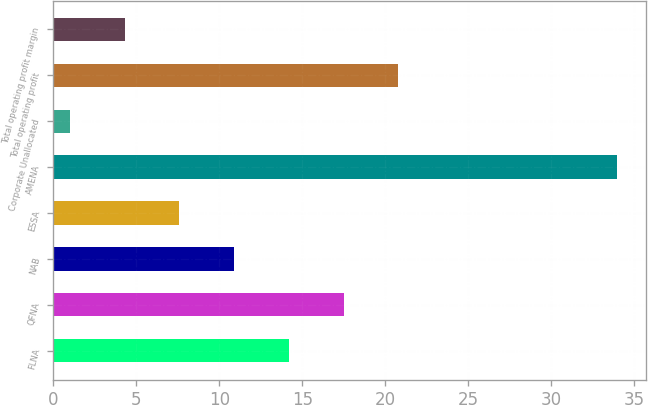Convert chart. <chart><loc_0><loc_0><loc_500><loc_500><bar_chart><fcel>FLNA<fcel>QFNA<fcel>NAB<fcel>ESSA<fcel>AMENA<fcel>Corporate Unallocated<fcel>Total operating profit<fcel>Total operating profit margin<nl><fcel>14.2<fcel>17.5<fcel>10.9<fcel>7.6<fcel>34<fcel>1<fcel>20.8<fcel>4.3<nl></chart> 